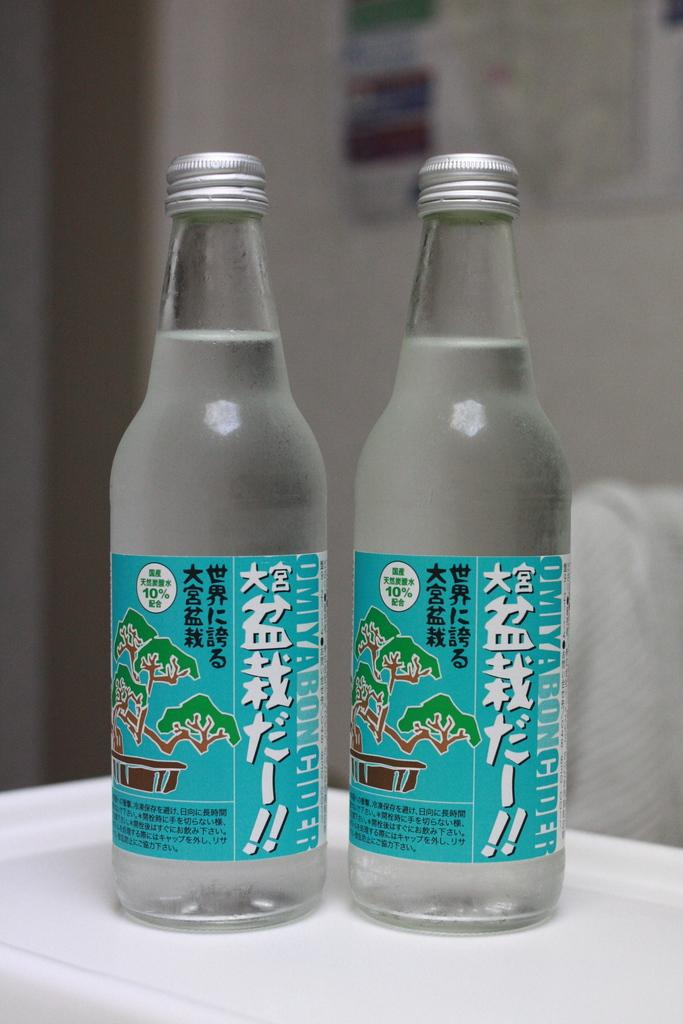<image>
Write a terse but informative summary of the picture. two bottles of Omiyaboncider that contains 10% of something 